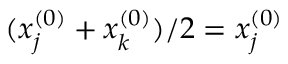Convert formula to latex. <formula><loc_0><loc_0><loc_500><loc_500>( x _ { j } ^ { ( 0 ) } + x _ { k } ^ { ( 0 ) } ) / 2 = x _ { j } ^ { ( 0 ) }</formula> 